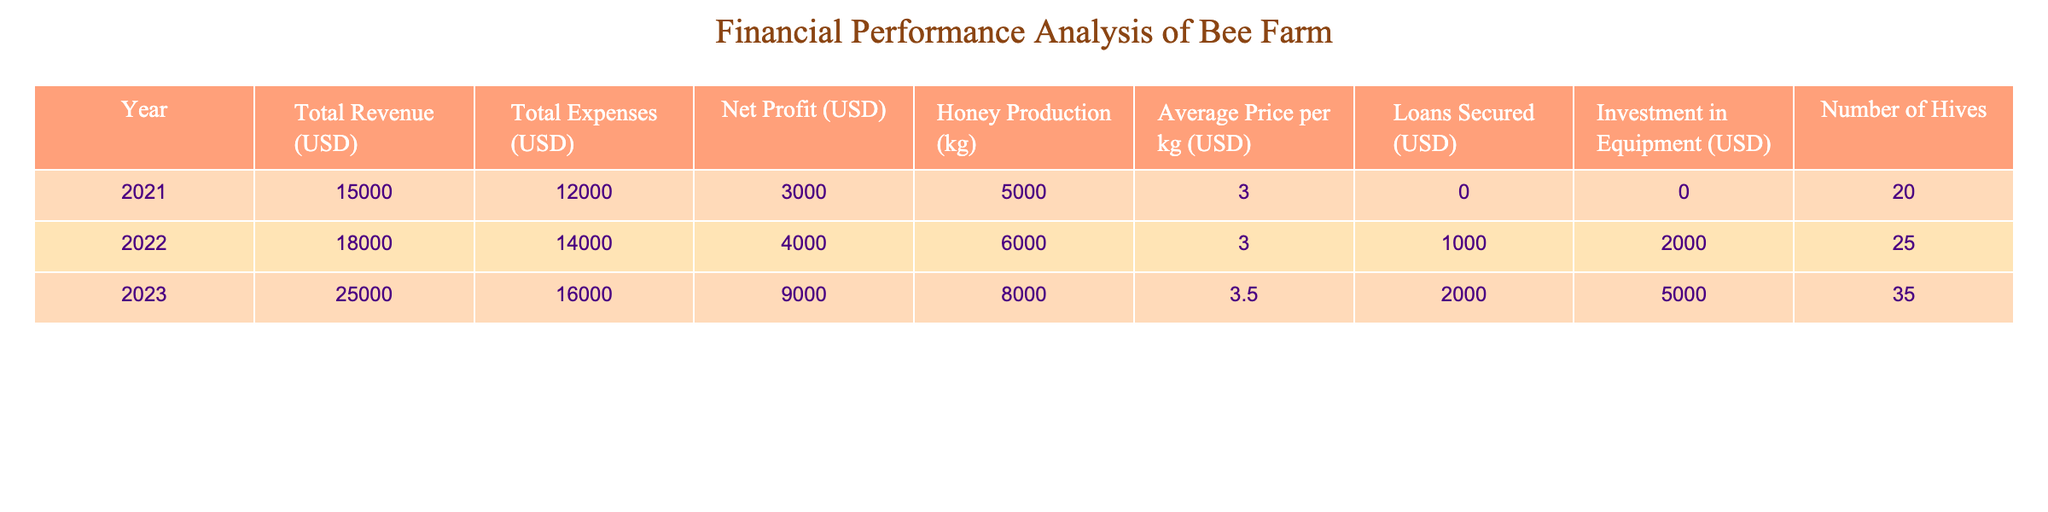What was the net profit for the year 2022? The table shows that in 2022, the Net Profit was listed as 4000 USD.
Answer: 4000 USD How much honey was produced in 2023? According to the table, the Honey Production for the year 2023 is listed as 8000 kg.
Answer: 8000 kg What is the total revenue for the years 2021 and 2022 combined? To find the total revenue for 2021 and 2022, we add the revenues: 15000 (2021) + 18000 (2022) = 33000 USD.
Answer: 33000 USD Was there an increase in the number of hives from 2021 to 2023? The number of hives in 2021 was 20, and in 2023 it increased to 35. Since 35 is greater than 20, there was an increase in the number of hives.
Answer: Yes What was the average price per kg of honey in 2022? The table indicates that in 2022, the Average Price per kg of honey was 3 USD. This refers directly to the column for that specific year.
Answer: 3 USD Calculate the change in net profit from 2021 to 2023. The Net Profit in 2021 was 3000 USD, and in 2023 it was 9000 USD. The change is calculated as 9000 (2023) - 3000 (2021) = 6000 USD. This shows that the net profit increased by 6000 USD over the two years.
Answer: 6000 USD Did the total expenses exceed total revenue in any year? Looking at the data, in 2021 the Total Expenses (12000 USD) were less than Total Revenue (15000 USD). In 2022, Expenses (14000 USD) were also less than Revenue (18000 USD). However, in 2023, Expenses (16000 USD) were still less than Revenue (25000 USD). Therefore, in none of the years did Total Expenses exceed Total Revenue.
Answer: No What was the total amount of loans secured across all three years? The table shows Loans Secured for each year: 0 USD (2021), 1000 USD (2022), and 2000 USD (2023). Adding these amounts gives the total: 0 + 1000 + 2000 = 3000 USD.
Answer: 3000 USD What was the change in the average price per kg of honey from 2021 to 2023? The Average Price per kg in 2021 was 3 USD, and in 2023 it increased to 3.5 USD. The change is calculated as 3.5 USD (2023) - 3 USD (2021) = 0.5 USD. Therefore, the average price increased by 0.5 USD per kg.
Answer: 0.5 USD 